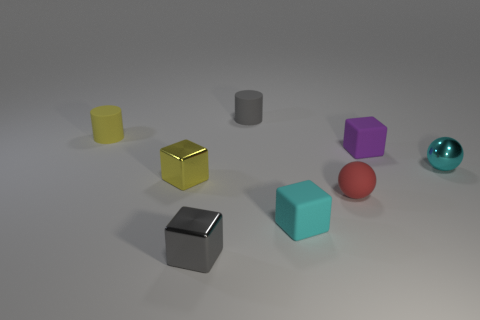There is another thing that is the same shape as the yellow rubber thing; what color is it?
Provide a succinct answer. Gray. What number of red rubber objects have the same shape as the cyan metal object?
Your response must be concise. 1. There is a thing that is the same color as the small shiny ball; what is it made of?
Your response must be concise. Rubber. What number of yellow metallic things are there?
Ensure brevity in your answer.  1. Is there a small red object that has the same material as the gray cylinder?
Give a very brief answer. Yes. What is the size of the cube that is the same color as the tiny metal sphere?
Your response must be concise. Small. There is a metallic cube in front of the matte sphere; is it the same size as the matte cube in front of the red object?
Your answer should be very brief. Yes. What size is the cyan thing that is in front of the cyan metallic object?
Provide a short and direct response. Small. Are there any cylinders of the same color as the shiny ball?
Provide a short and direct response. No. There is a rubber block that is in front of the tiny purple rubber block; are there any cylinders in front of it?
Ensure brevity in your answer.  No. 